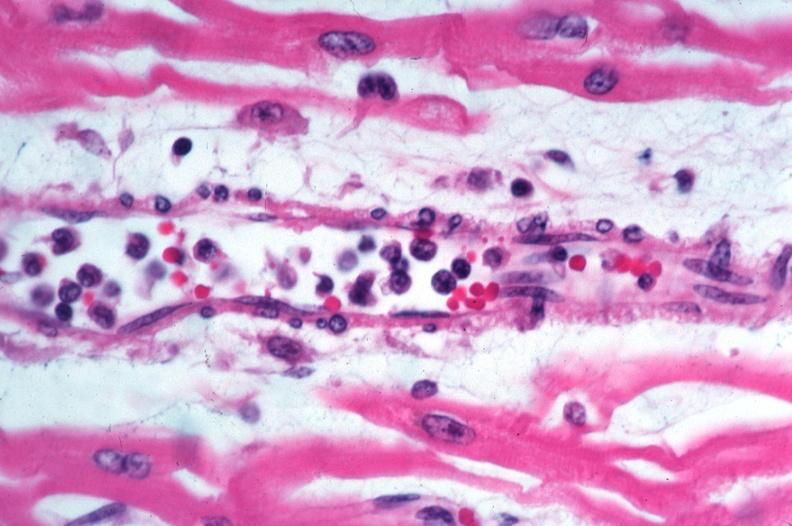s metastatic malignant ependymoma spotted fever, vasculitis?
Answer the question using a single word or phrase. No 